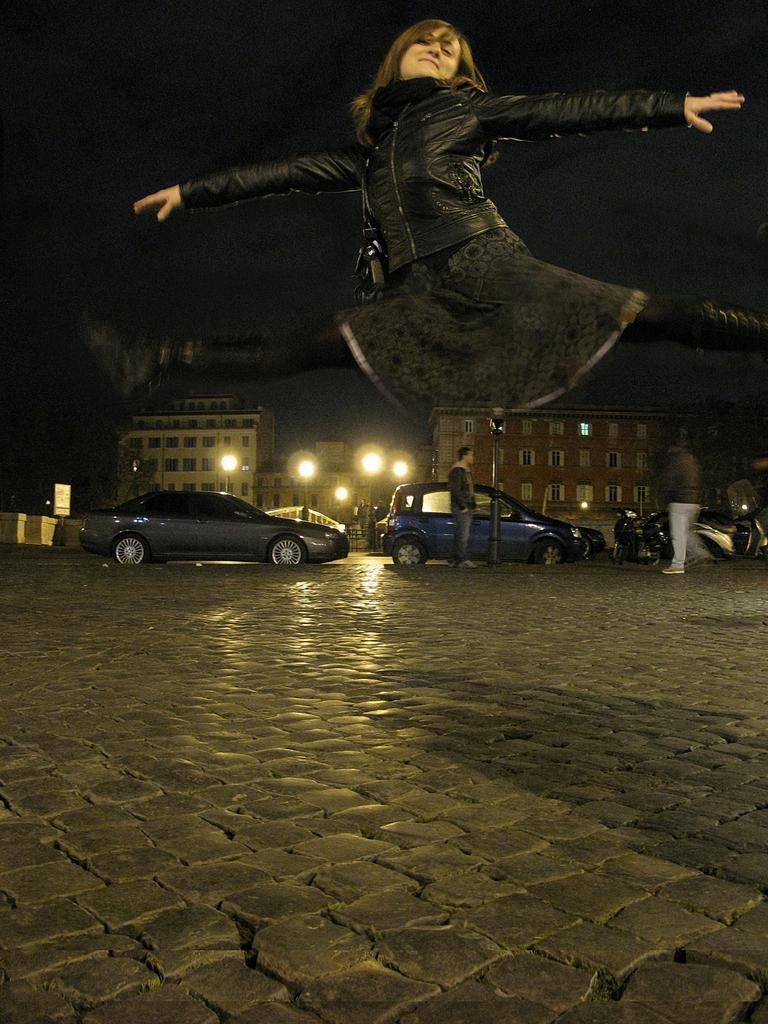Describe this image in one or two sentences. In the picture we can see a rock tile surface and some woman is jumping and she is wearing a black dress and in the background, we can see some cars, poles with lights and behind it we can see buildings with windows. 